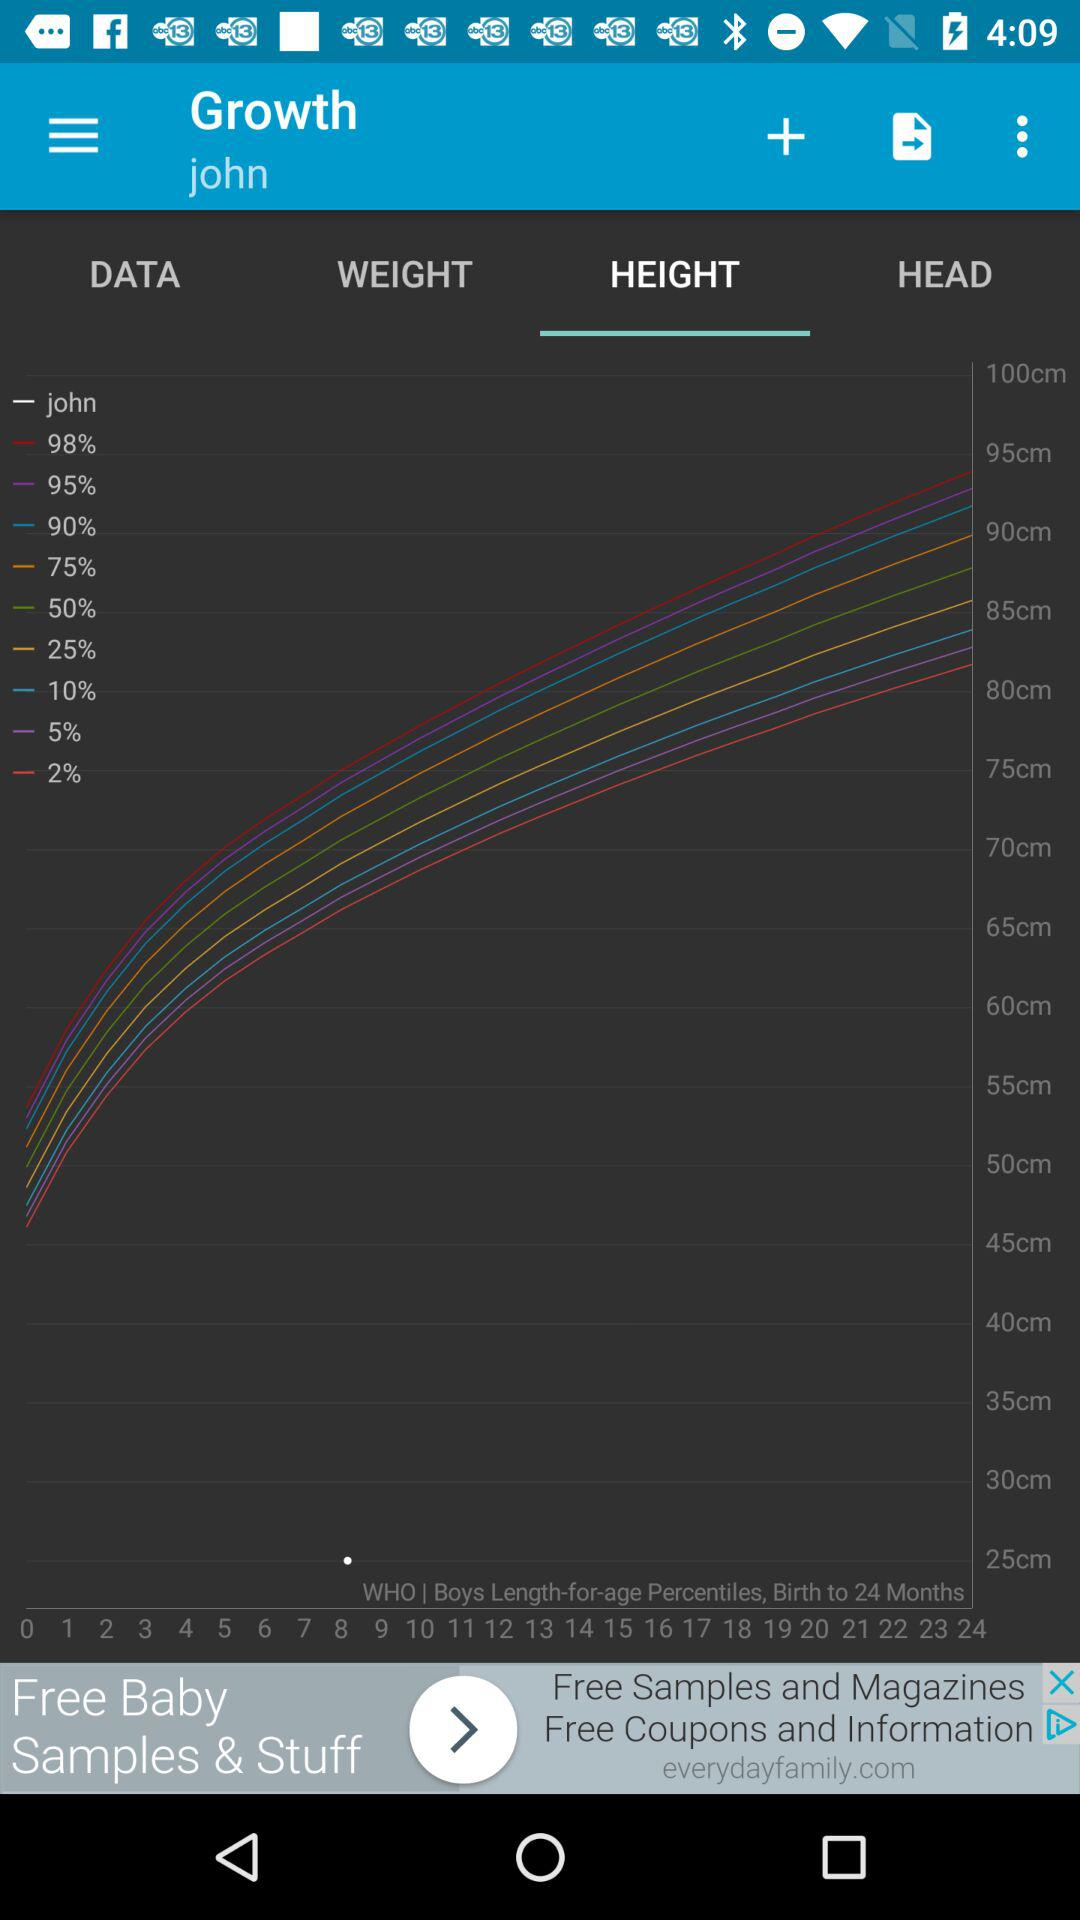What is the name of the user? The name of the user is John. 